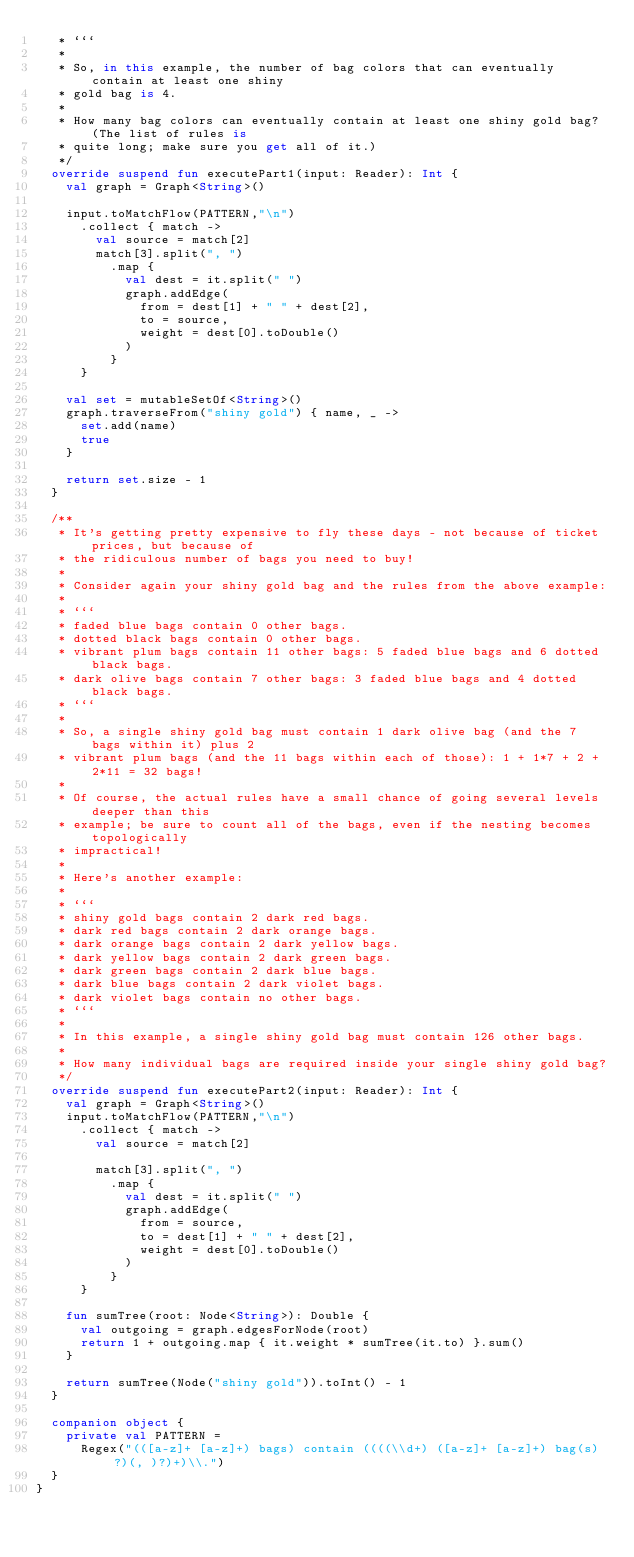Convert code to text. <code><loc_0><loc_0><loc_500><loc_500><_Kotlin_>   * ```
   *
   * So, in this example, the number of bag colors that can eventually contain at least one shiny
   * gold bag is 4.
   *
   * How many bag colors can eventually contain at least one shiny gold bag? (The list of rules is
   * quite long; make sure you get all of it.)
   */
  override suspend fun executePart1(input: Reader): Int {
    val graph = Graph<String>()

    input.toMatchFlow(PATTERN,"\n")
      .collect { match ->
        val source = match[2]
        match[3].split(", ")
          .map {
            val dest = it.split(" ")
            graph.addEdge(
              from = dest[1] + " " + dest[2],
              to = source,
              weight = dest[0].toDouble()
            )
          }
      }

    val set = mutableSetOf<String>()
    graph.traverseFrom("shiny gold") { name, _ ->
      set.add(name)
      true
    }

    return set.size - 1
  }

  /**
   * It's getting pretty expensive to fly these days - not because of ticket prices, but because of
   * the ridiculous number of bags you need to buy!
   *
   * Consider again your shiny gold bag and the rules from the above example:
   *
   * ```
   * faded blue bags contain 0 other bags.
   * dotted black bags contain 0 other bags.
   * vibrant plum bags contain 11 other bags: 5 faded blue bags and 6 dotted black bags.
   * dark olive bags contain 7 other bags: 3 faded blue bags and 4 dotted black bags.
   * ```
   *
   * So, a single shiny gold bag must contain 1 dark olive bag (and the 7 bags within it) plus 2
   * vibrant plum bags (and the 11 bags within each of those): 1 + 1*7 + 2 + 2*11 = 32 bags!
   *
   * Of course, the actual rules have a small chance of going several levels deeper than this
   * example; be sure to count all of the bags, even if the nesting becomes topologically
   * impractical!
   *
   * Here's another example:
   *
   * ```
   * shiny gold bags contain 2 dark red bags.
   * dark red bags contain 2 dark orange bags.
   * dark orange bags contain 2 dark yellow bags.
   * dark yellow bags contain 2 dark green bags.
   * dark green bags contain 2 dark blue bags.
   * dark blue bags contain 2 dark violet bags.
   * dark violet bags contain no other bags.
   * ```
   *
   * In this example, a single shiny gold bag must contain 126 other bags.
   *
   * How many individual bags are required inside your single shiny gold bag?
   */
  override suspend fun executePart2(input: Reader): Int {
    val graph = Graph<String>()
    input.toMatchFlow(PATTERN,"\n")
      .collect { match ->
        val source = match[2]

        match[3].split(", ")
          .map {
            val dest = it.split(" ")
            graph.addEdge(
              from = source,
              to = dest[1] + " " + dest[2],
              weight = dest[0].toDouble()
            )
          }
      }

    fun sumTree(root: Node<String>): Double {
      val outgoing = graph.edgesForNode(root)
      return 1 + outgoing.map { it.weight * sumTree(it.to) }.sum()
    }

    return sumTree(Node("shiny gold")).toInt() - 1
  }

  companion object {
    private val PATTERN =
      Regex("(([a-z]+ [a-z]+) bags) contain ((((\\d+) ([a-z]+ [a-z]+) bag(s)?)(, )?)+)\\.")
  }
}</code> 